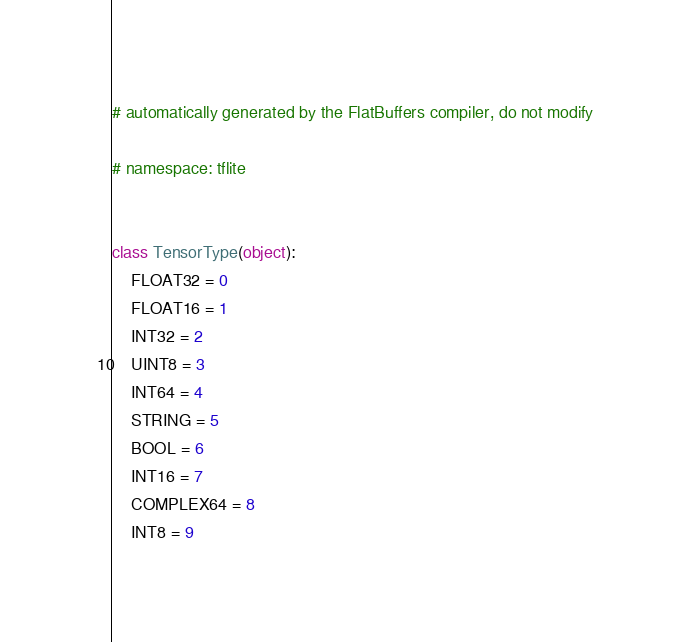<code> <loc_0><loc_0><loc_500><loc_500><_Python_># automatically generated by the FlatBuffers compiler, do not modify

# namespace: tflite


class TensorType(object):
    FLOAT32 = 0
    FLOAT16 = 1
    INT32 = 2
    UINT8 = 3
    INT64 = 4
    STRING = 5
    BOOL = 6
    INT16 = 7
    COMPLEX64 = 8
    INT8 = 9
</code> 